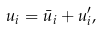Convert formula to latex. <formula><loc_0><loc_0><loc_500><loc_500>u _ { i } = \bar { u } _ { i } + u _ { i } ^ { \prime } ,</formula> 